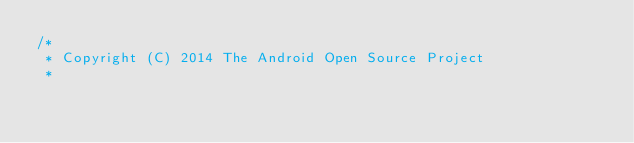Convert code to text. <code><loc_0><loc_0><loc_500><loc_500><_Java_>/*
 * Copyright (C) 2014 The Android Open Source Project
 *</code> 